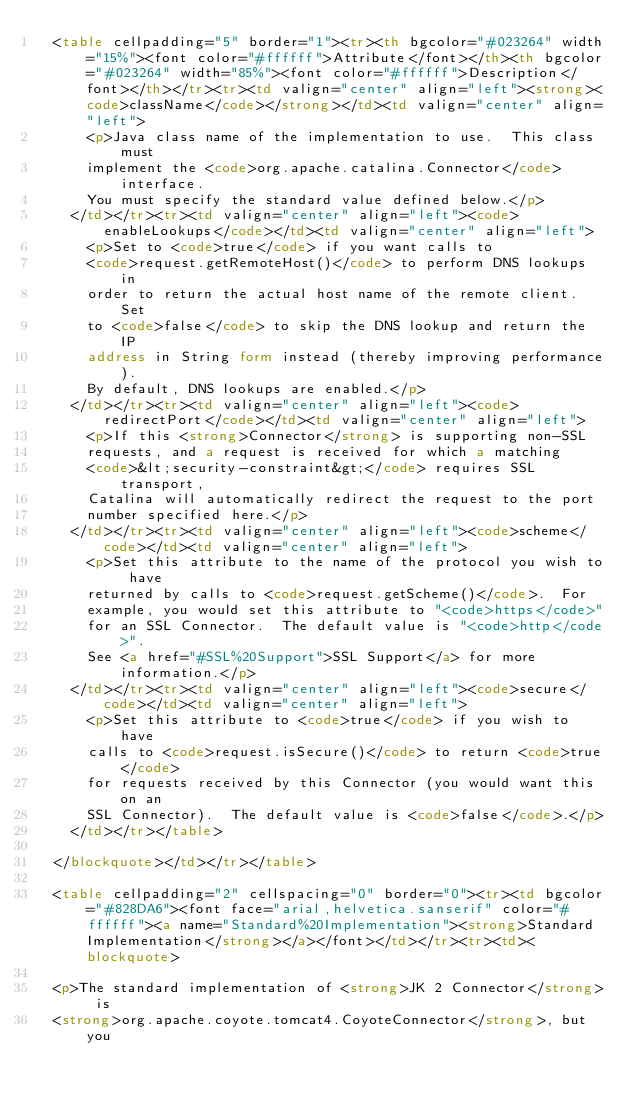Convert code to text. <code><loc_0><loc_0><loc_500><loc_500><_HTML_>  <table cellpadding="5" border="1"><tr><th bgcolor="#023264" width="15%"><font color="#ffffff">Attribute</font></th><th bgcolor="#023264" width="85%"><font color="#ffffff">Description</font></th></tr><tr><td valign="center" align="left"><strong><code>className</code></strong></td><td valign="center" align="left">
      <p>Java class name of the implementation to use.  This class must
      implement the <code>org.apache.catalina.Connector</code> interface.
      You must specify the standard value defined below.</p>
    </td></tr><tr><td valign="center" align="left"><code>enableLookups</code></td><td valign="center" align="left">
      <p>Set to <code>true</code> if you want calls to
      <code>request.getRemoteHost()</code> to perform DNS lookups in
      order to return the actual host name of the remote client.  Set
      to <code>false</code> to skip the DNS lookup and return the IP
      address in String form instead (thereby improving performance).
      By default, DNS lookups are enabled.</p>
    </td></tr><tr><td valign="center" align="left"><code>redirectPort</code></td><td valign="center" align="left">
      <p>If this <strong>Connector</strong> is supporting non-SSL
      requests, and a request is received for which a matching
      <code>&lt;security-constraint&gt;</code> requires SSL transport,
      Catalina will automatically redirect the request to the port
      number specified here.</p>
    </td></tr><tr><td valign="center" align="left"><code>scheme</code></td><td valign="center" align="left">
      <p>Set this attribute to the name of the protocol you wish to have
      returned by calls to <code>request.getScheme()</code>.  For
      example, you would set this attribute to "<code>https</code>"
      for an SSL Connector.  The default value is "<code>http</code>".
      See <a href="#SSL%20Support">SSL Support</a> for more information.</p>
    </td></tr><tr><td valign="center" align="left"><code>secure</code></td><td valign="center" align="left">
      <p>Set this attribute to <code>true</code> if you wish to have
      calls to <code>request.isSecure()</code> to return <code>true</code>
      for requests received by this Connector (you would want this on an
      SSL Connector).  The default value is <code>false</code>.</p>
    </td></tr></table>

  </blockquote></td></tr></table>

  <table cellpadding="2" cellspacing="0" border="0"><tr><td bgcolor="#828DA6"><font face="arial,helvetica.sanserif" color="#ffffff"><a name="Standard%20Implementation"><strong>Standard Implementation</strong></a></font></td></tr><tr><td><blockquote>

  <p>The standard implementation of <strong>JK 2 Connector</strong> is
  <strong>org.apache.coyote.tomcat4.CoyoteConnector</strong>, but you</code> 